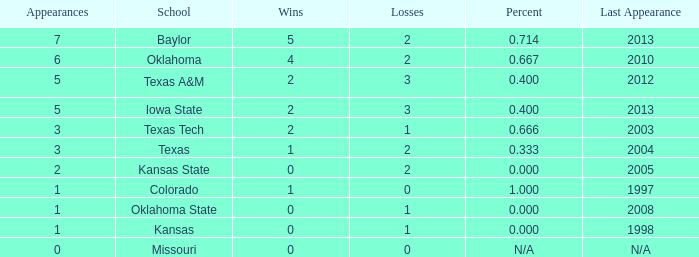What is the count of baylor's wins? 1.0. 